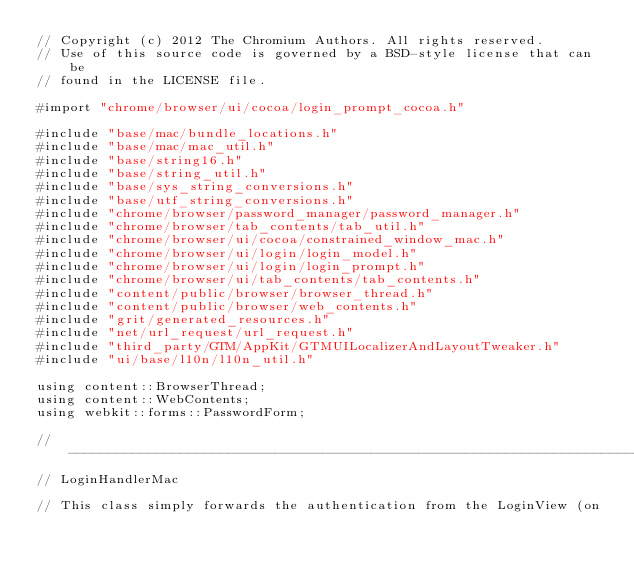Convert code to text. <code><loc_0><loc_0><loc_500><loc_500><_ObjectiveC_>// Copyright (c) 2012 The Chromium Authors. All rights reserved.
// Use of this source code is governed by a BSD-style license that can be
// found in the LICENSE file.

#import "chrome/browser/ui/cocoa/login_prompt_cocoa.h"

#include "base/mac/bundle_locations.h"
#include "base/mac/mac_util.h"
#include "base/string16.h"
#include "base/string_util.h"
#include "base/sys_string_conversions.h"
#include "base/utf_string_conversions.h"
#include "chrome/browser/password_manager/password_manager.h"
#include "chrome/browser/tab_contents/tab_util.h"
#include "chrome/browser/ui/cocoa/constrained_window_mac.h"
#include "chrome/browser/ui/login/login_model.h"
#include "chrome/browser/ui/login/login_prompt.h"
#include "chrome/browser/ui/tab_contents/tab_contents.h"
#include "content/public/browser/browser_thread.h"
#include "content/public/browser/web_contents.h"
#include "grit/generated_resources.h"
#include "net/url_request/url_request.h"
#include "third_party/GTM/AppKit/GTMUILocalizerAndLayoutTweaker.h"
#include "ui/base/l10n/l10n_util.h"

using content::BrowserThread;
using content::WebContents;
using webkit::forms::PasswordForm;

// ----------------------------------------------------------------------------
// LoginHandlerMac

// This class simply forwards the authentication from the LoginView (on</code> 